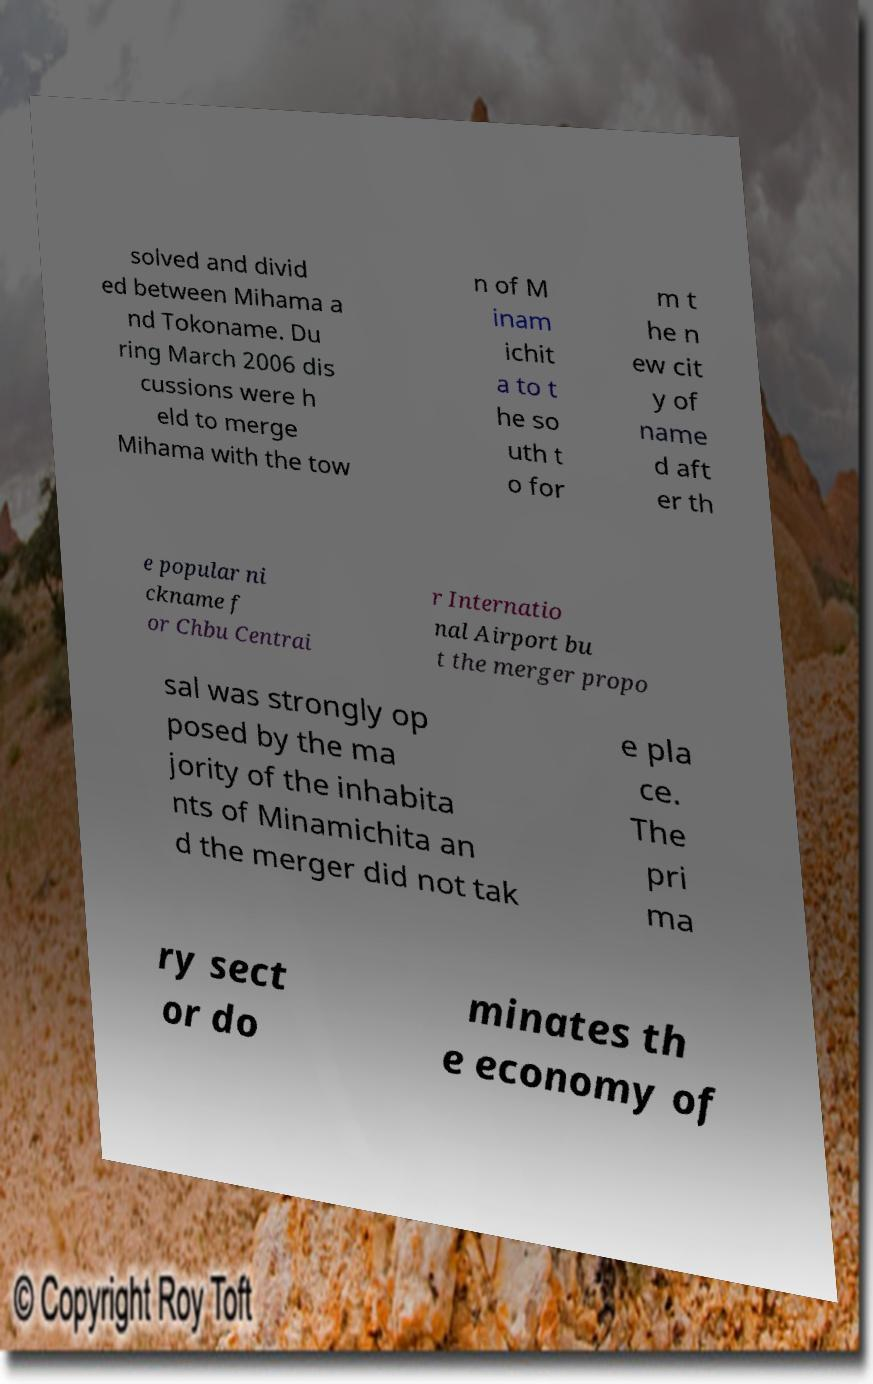Could you assist in decoding the text presented in this image and type it out clearly? solved and divid ed between Mihama a nd Tokoname. Du ring March 2006 dis cussions were h eld to merge Mihama with the tow n of M inam ichit a to t he so uth t o for m t he n ew cit y of name d aft er th e popular ni ckname f or Chbu Centrai r Internatio nal Airport bu t the merger propo sal was strongly op posed by the ma jority of the inhabita nts of Minamichita an d the merger did not tak e pla ce. The pri ma ry sect or do minates th e economy of 